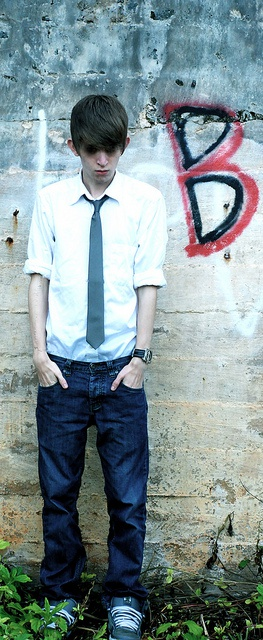Describe the objects in this image and their specific colors. I can see people in teal, white, black, navy, and darkgray tones and tie in teal, gray, and blue tones in this image. 